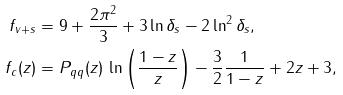<formula> <loc_0><loc_0><loc_500><loc_500>f _ { v + s } & = 9 + \frac { 2 \pi ^ { 2 } } { 3 } + 3 \ln \delta _ { s } - 2 \ln ^ { 2 } \delta _ { s } , \\ f _ { c } ( z ) & = P _ { q q } ( z ) \, \ln \left ( \frac { 1 - z } { z } \right ) - \frac { 3 } { 2 } \frac { 1 } { 1 - z } + 2 z + 3 ,</formula> 